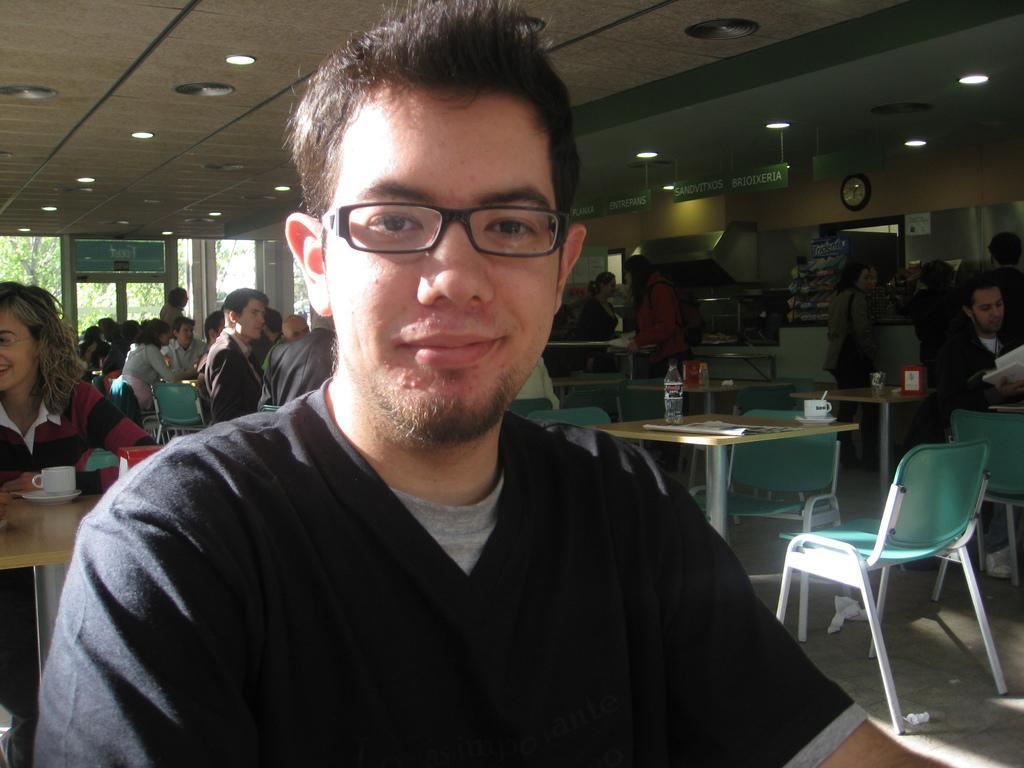Can you describe this image briefly? As we can see in he image there is a white color wall, clock, banner, few people sitting on chairs and tables. On tables there are newspaper, bottle and cup. 